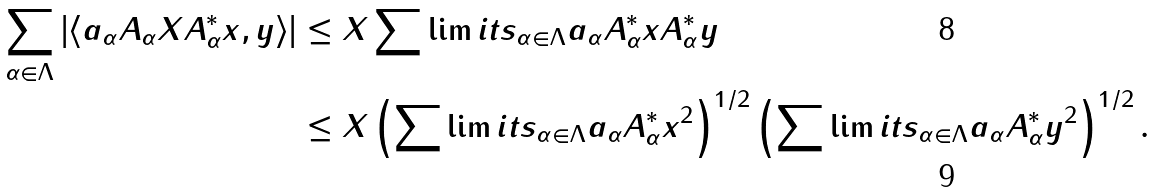Convert formula to latex. <formula><loc_0><loc_0><loc_500><loc_500>\sum _ { \alpha \in \Lambda } \left | \left < a _ { \alpha } A _ { \alpha } X A _ { \alpha } ^ { * } x , y \right > \right | & \leq \| X \| \sum \lim i t s _ { \alpha \in \Lambda } a _ { \alpha } \| A _ { \alpha } ^ { * } x \| \| A _ { \alpha } ^ { * } y \| \\ & \leq \| X \| \left ( \sum \lim i t s _ { \alpha \in \Lambda } a _ { \alpha } \| A _ { \alpha } ^ { * } x \| ^ { 2 } \right ) ^ { 1 / 2 } \left ( \sum \lim i t s _ { \alpha \in \Lambda } a _ { \alpha } \| A _ { \alpha } ^ { * } y \| ^ { 2 } \right ) ^ { 1 / 2 } .</formula> 